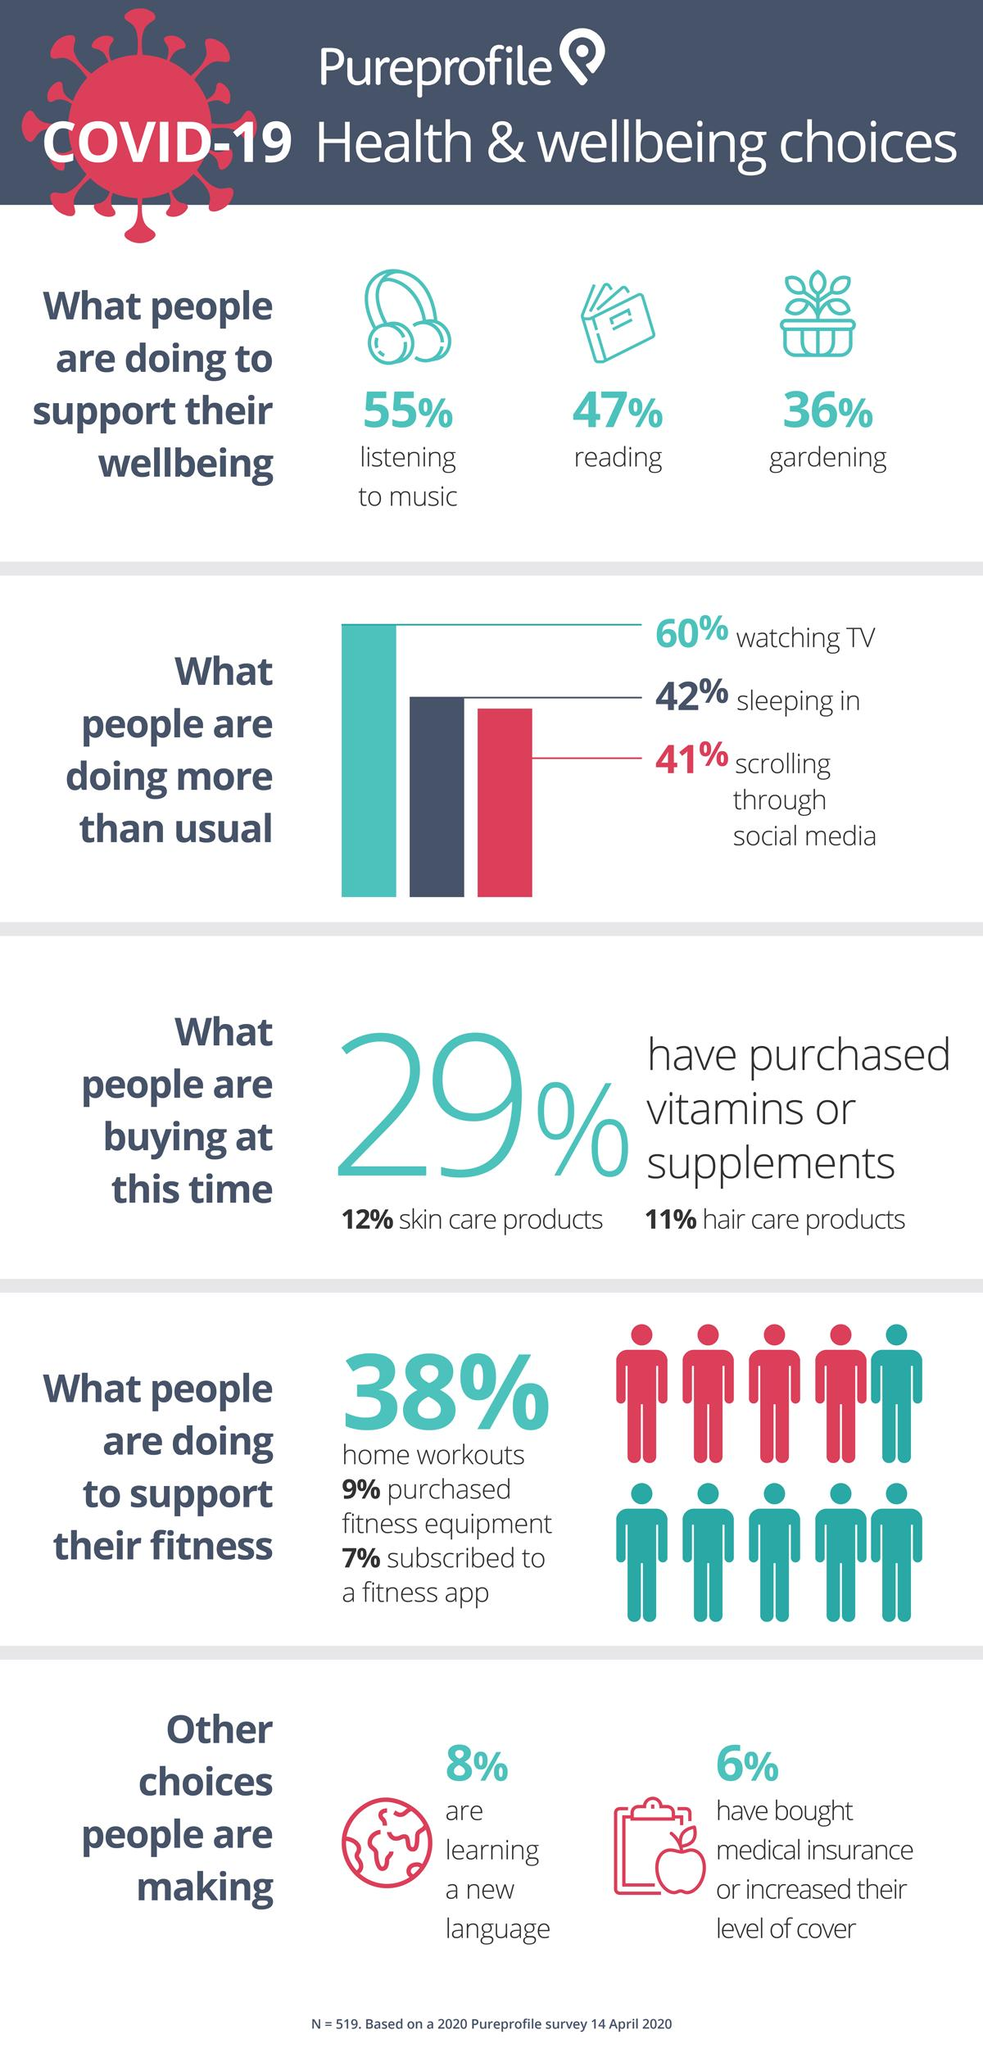List a handful of essential elements in this visual. During these times, people are primarily purchasing vitamins or supplements, skin care products, and hair care products. According to recent studies, it has been found that approximately 8% of people are actively learning a new language. According to a recent study, 47% of people read to support their overall well-being. According to a recent survey, 38% of individuals report that they regularly work out at home. According to a recent survey, a significant percentage of people, approximately 55%, are listening to music as a way to support their overall wellbeing. 